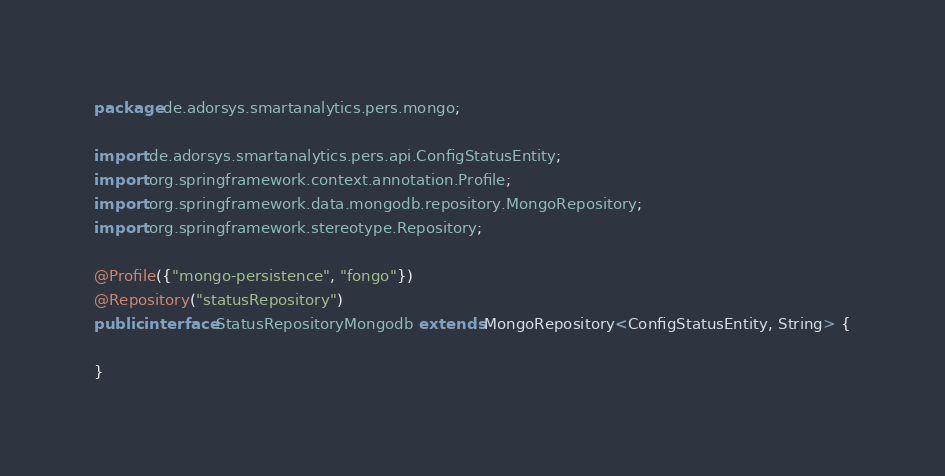<code> <loc_0><loc_0><loc_500><loc_500><_Java_>package de.adorsys.smartanalytics.pers.mongo;

import de.adorsys.smartanalytics.pers.api.ConfigStatusEntity;
import org.springframework.context.annotation.Profile;
import org.springframework.data.mongodb.repository.MongoRepository;
import org.springframework.stereotype.Repository;

@Profile({"mongo-persistence", "fongo"})
@Repository("statusRepository")
public interface StatusRepositoryMongodb extends MongoRepository<ConfigStatusEntity, String> {

}</code> 